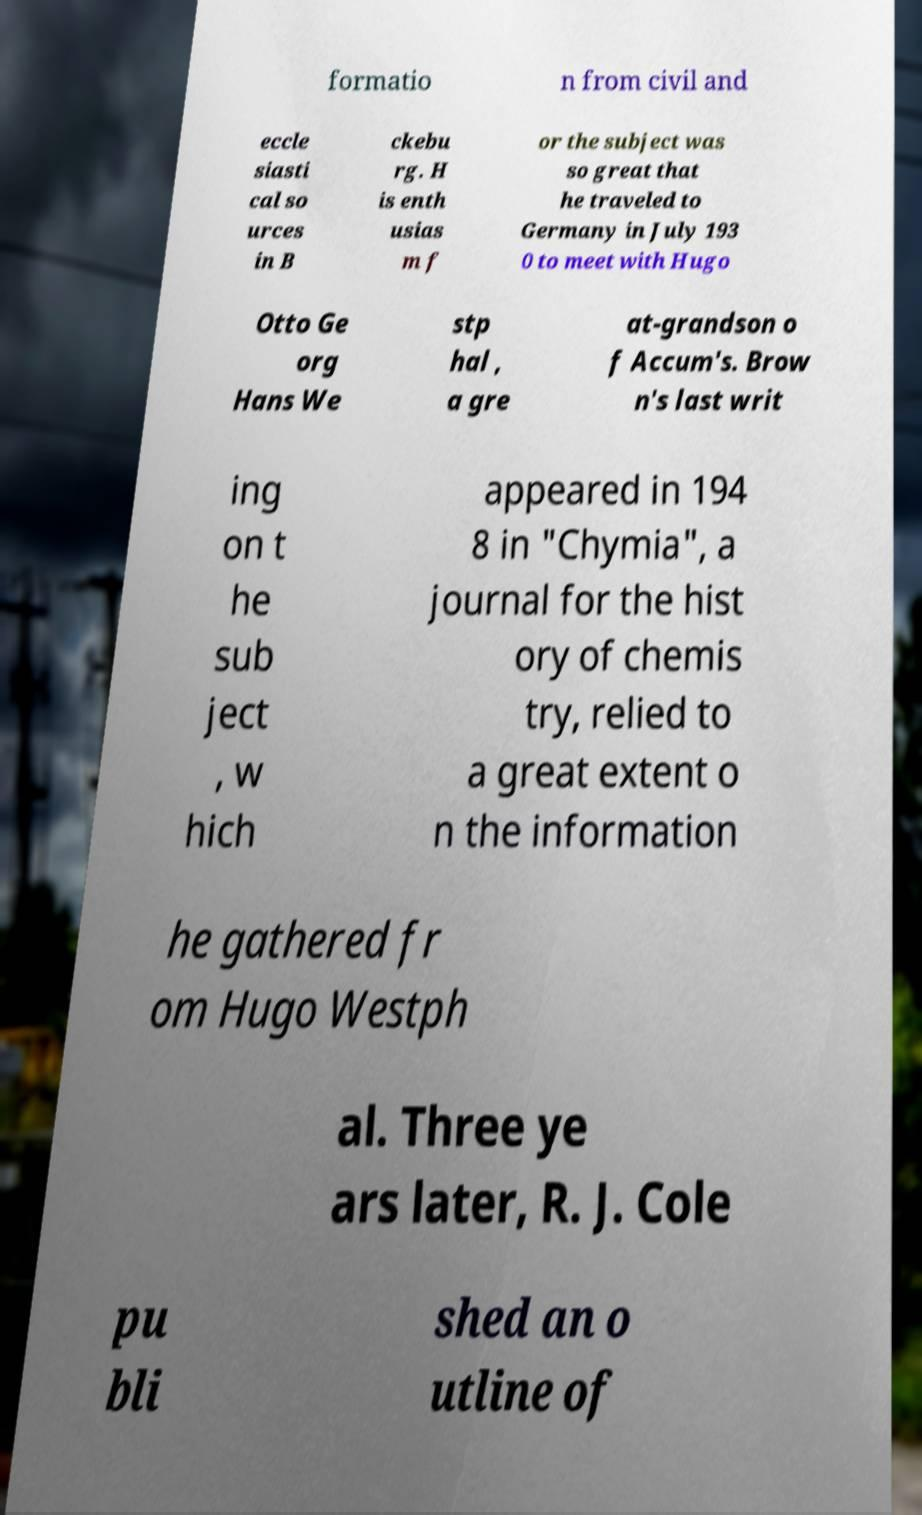Can you accurately transcribe the text from the provided image for me? formatio n from civil and eccle siasti cal so urces in B ckebu rg. H is enth usias m f or the subject was so great that he traveled to Germany in July 193 0 to meet with Hugo Otto Ge org Hans We stp hal , a gre at-grandson o f Accum's. Brow n's last writ ing on t he sub ject , w hich appeared in 194 8 in "Chymia", a journal for the hist ory of chemis try, relied to a great extent o n the information he gathered fr om Hugo Westph al. Three ye ars later, R. J. Cole pu bli shed an o utline of 